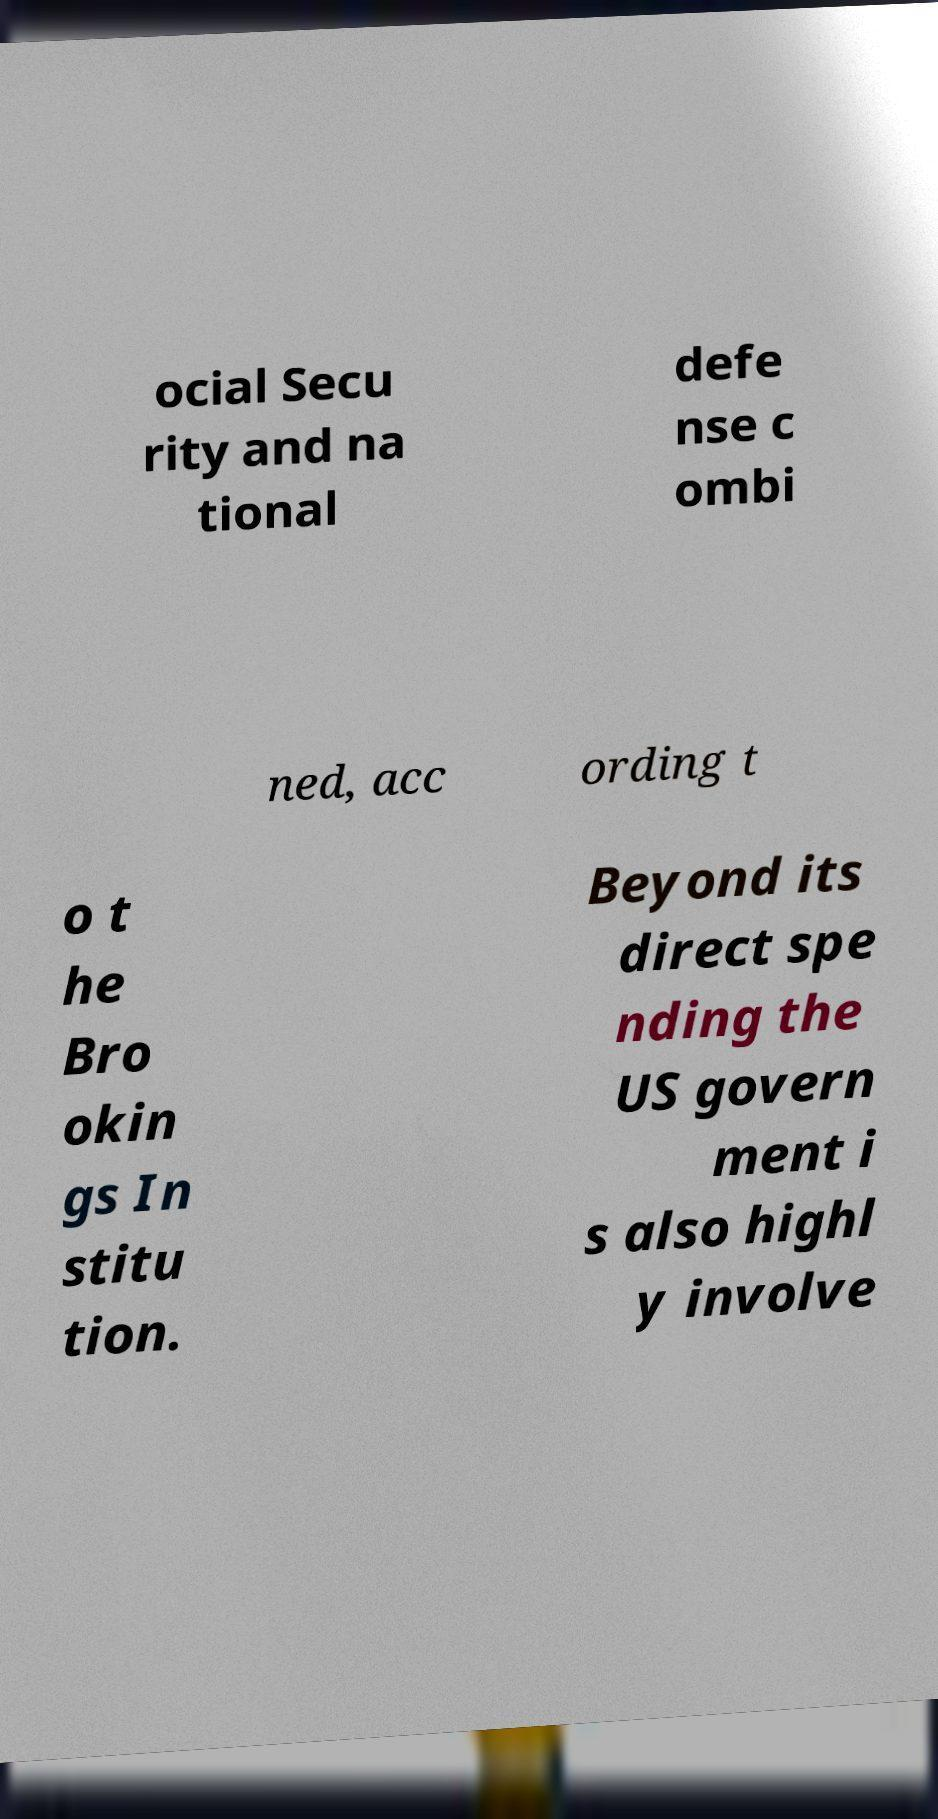Please read and relay the text visible in this image. What does it say? ocial Secu rity and na tional defe nse c ombi ned, acc ording t o t he Bro okin gs In stitu tion. Beyond its direct spe nding the US govern ment i s also highl y involve 